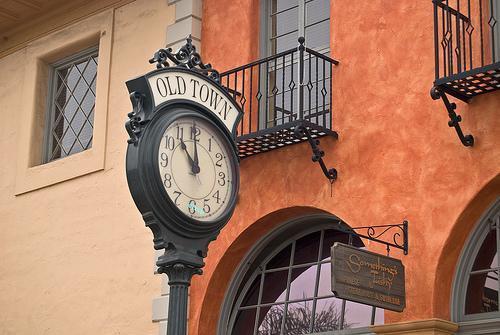How many signs are handing on the buildings?
Give a very brief answer. 1. How many railings are on the orange building?
Give a very brief answer. 2. 